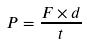Convert formula to latex. <formula><loc_0><loc_0><loc_500><loc_500>P = \frac { F \times d } { t }</formula> 